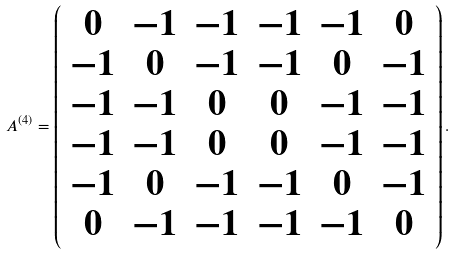Convert formula to latex. <formula><loc_0><loc_0><loc_500><loc_500>A ^ { ( 4 ) } = \left ( \begin{array} { c c c c c c } 0 & - 1 & - 1 & - 1 & - 1 & 0 \\ - 1 & 0 & - 1 & - 1 & 0 & - 1 \\ - 1 & - 1 & 0 & 0 & - 1 & - 1 \\ - 1 & - 1 & 0 & 0 & - 1 & - 1 \\ - 1 & 0 & - 1 & - 1 & 0 & - 1 \\ 0 & - 1 & - 1 & - 1 & - 1 & 0 \end{array} \right ) .</formula> 